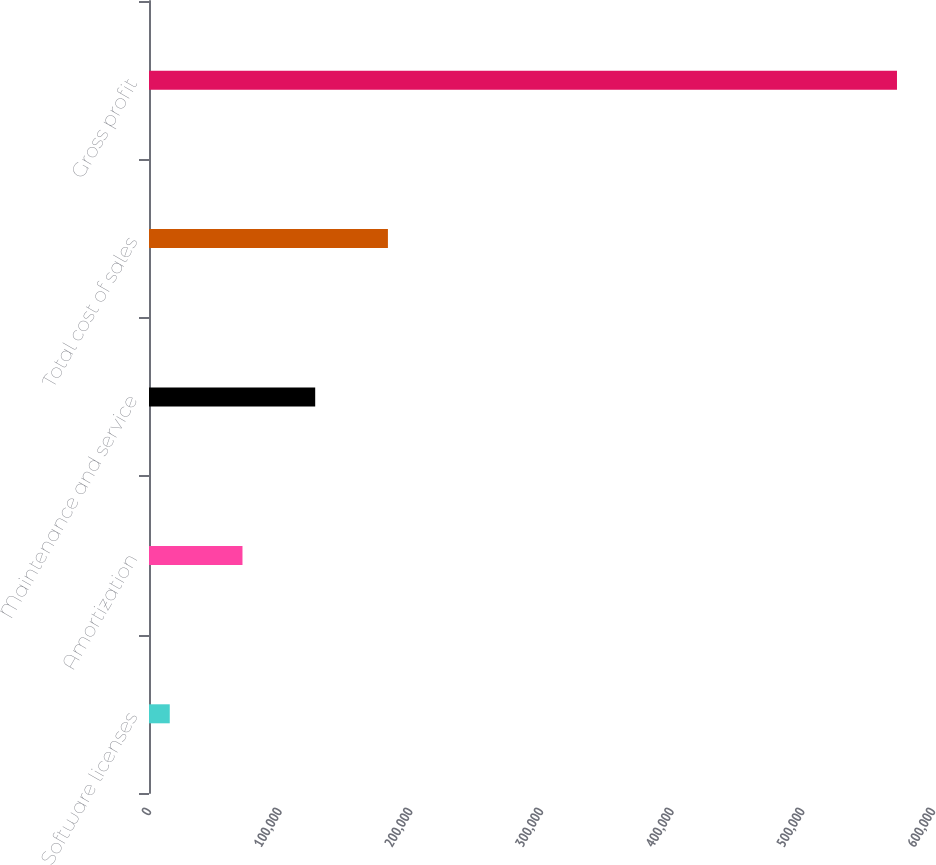<chart> <loc_0><loc_0><loc_500><loc_500><bar_chart><fcel>Software licenses<fcel>Amortization<fcel>Maintenance and service<fcel>Total cost of sales<fcel>Gross profit<nl><fcel>15884<fcel>71539.1<fcel>127194<fcel>182849<fcel>572435<nl></chart> 